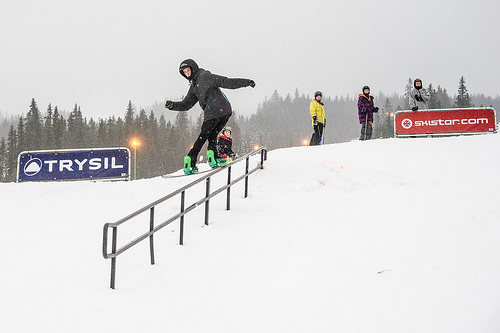Which color is the jacket the person is wearing? One person is wearing a vibrant purple jacket, standing out against the snowy background. 